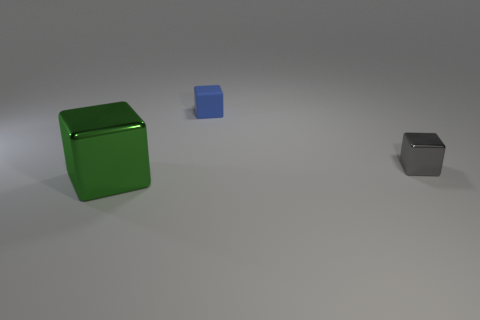Subtract all tiny metal blocks. How many blocks are left? 2 Add 2 tiny brown rubber cubes. How many objects exist? 5 Subtract all brown blocks. Subtract all cyan balls. How many blocks are left? 3 Subtract all large cyan metallic cylinders. Subtract all green things. How many objects are left? 2 Add 1 gray things. How many gray things are left? 2 Add 2 small gray metallic things. How many small gray metallic things exist? 3 Subtract 0 yellow cylinders. How many objects are left? 3 